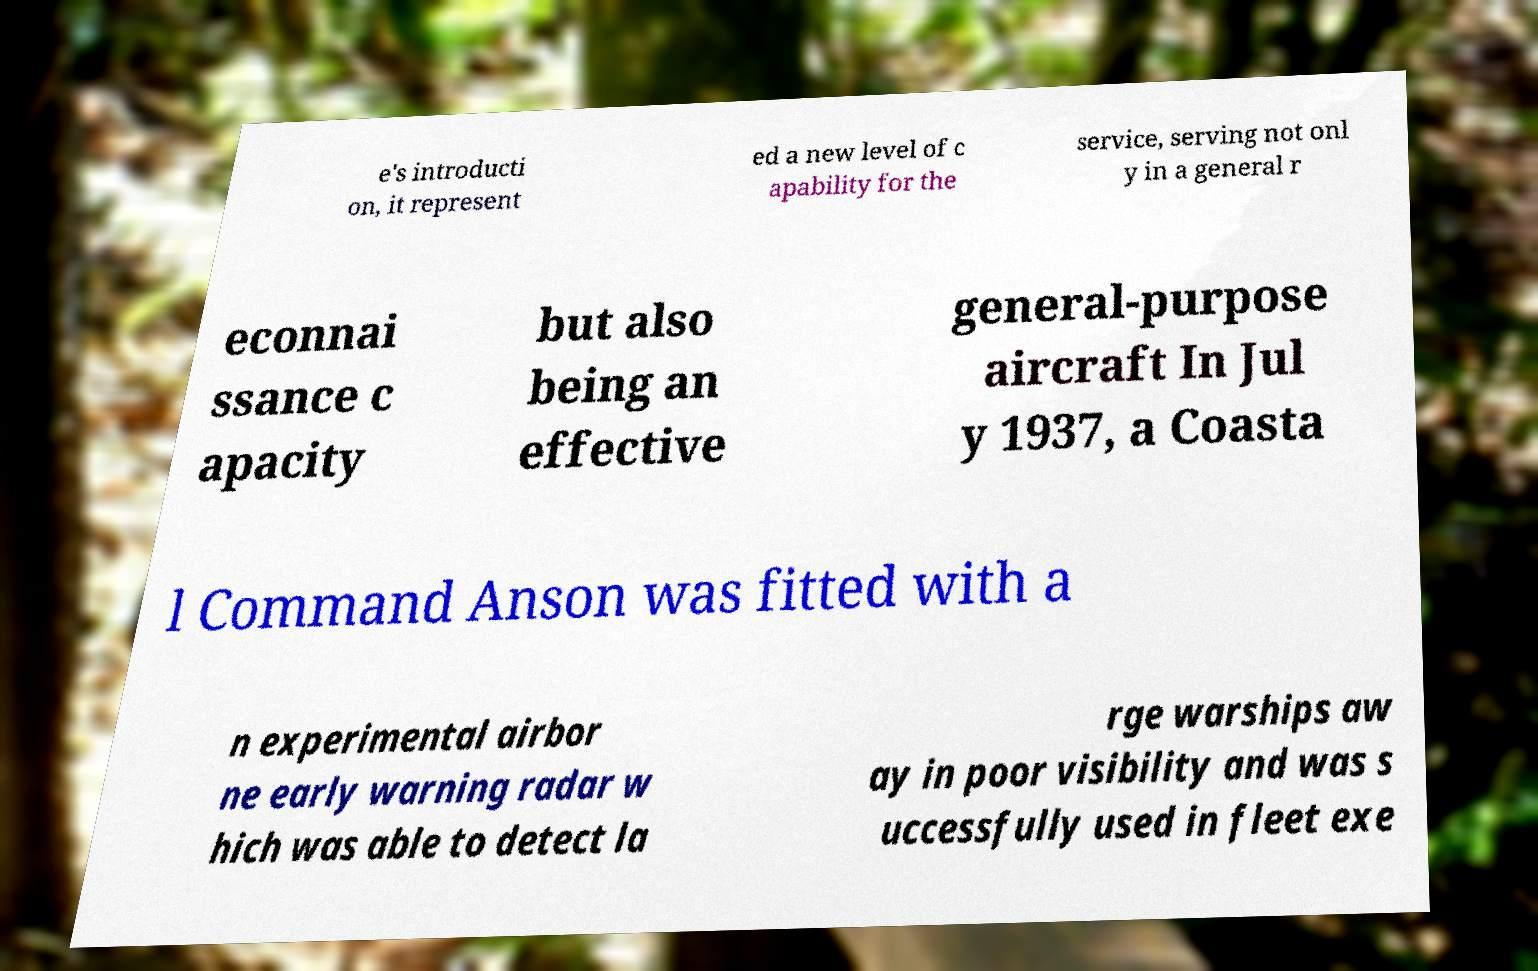For documentation purposes, I need the text within this image transcribed. Could you provide that? e's introducti on, it represent ed a new level of c apability for the service, serving not onl y in a general r econnai ssance c apacity but also being an effective general-purpose aircraft In Jul y 1937, a Coasta l Command Anson was fitted with a n experimental airbor ne early warning radar w hich was able to detect la rge warships aw ay in poor visibility and was s uccessfully used in fleet exe 